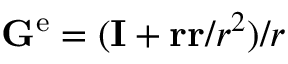<formula> <loc_0><loc_0><loc_500><loc_500>G ^ { e } = ( I + r r / r ^ { 2 } ) / r</formula> 